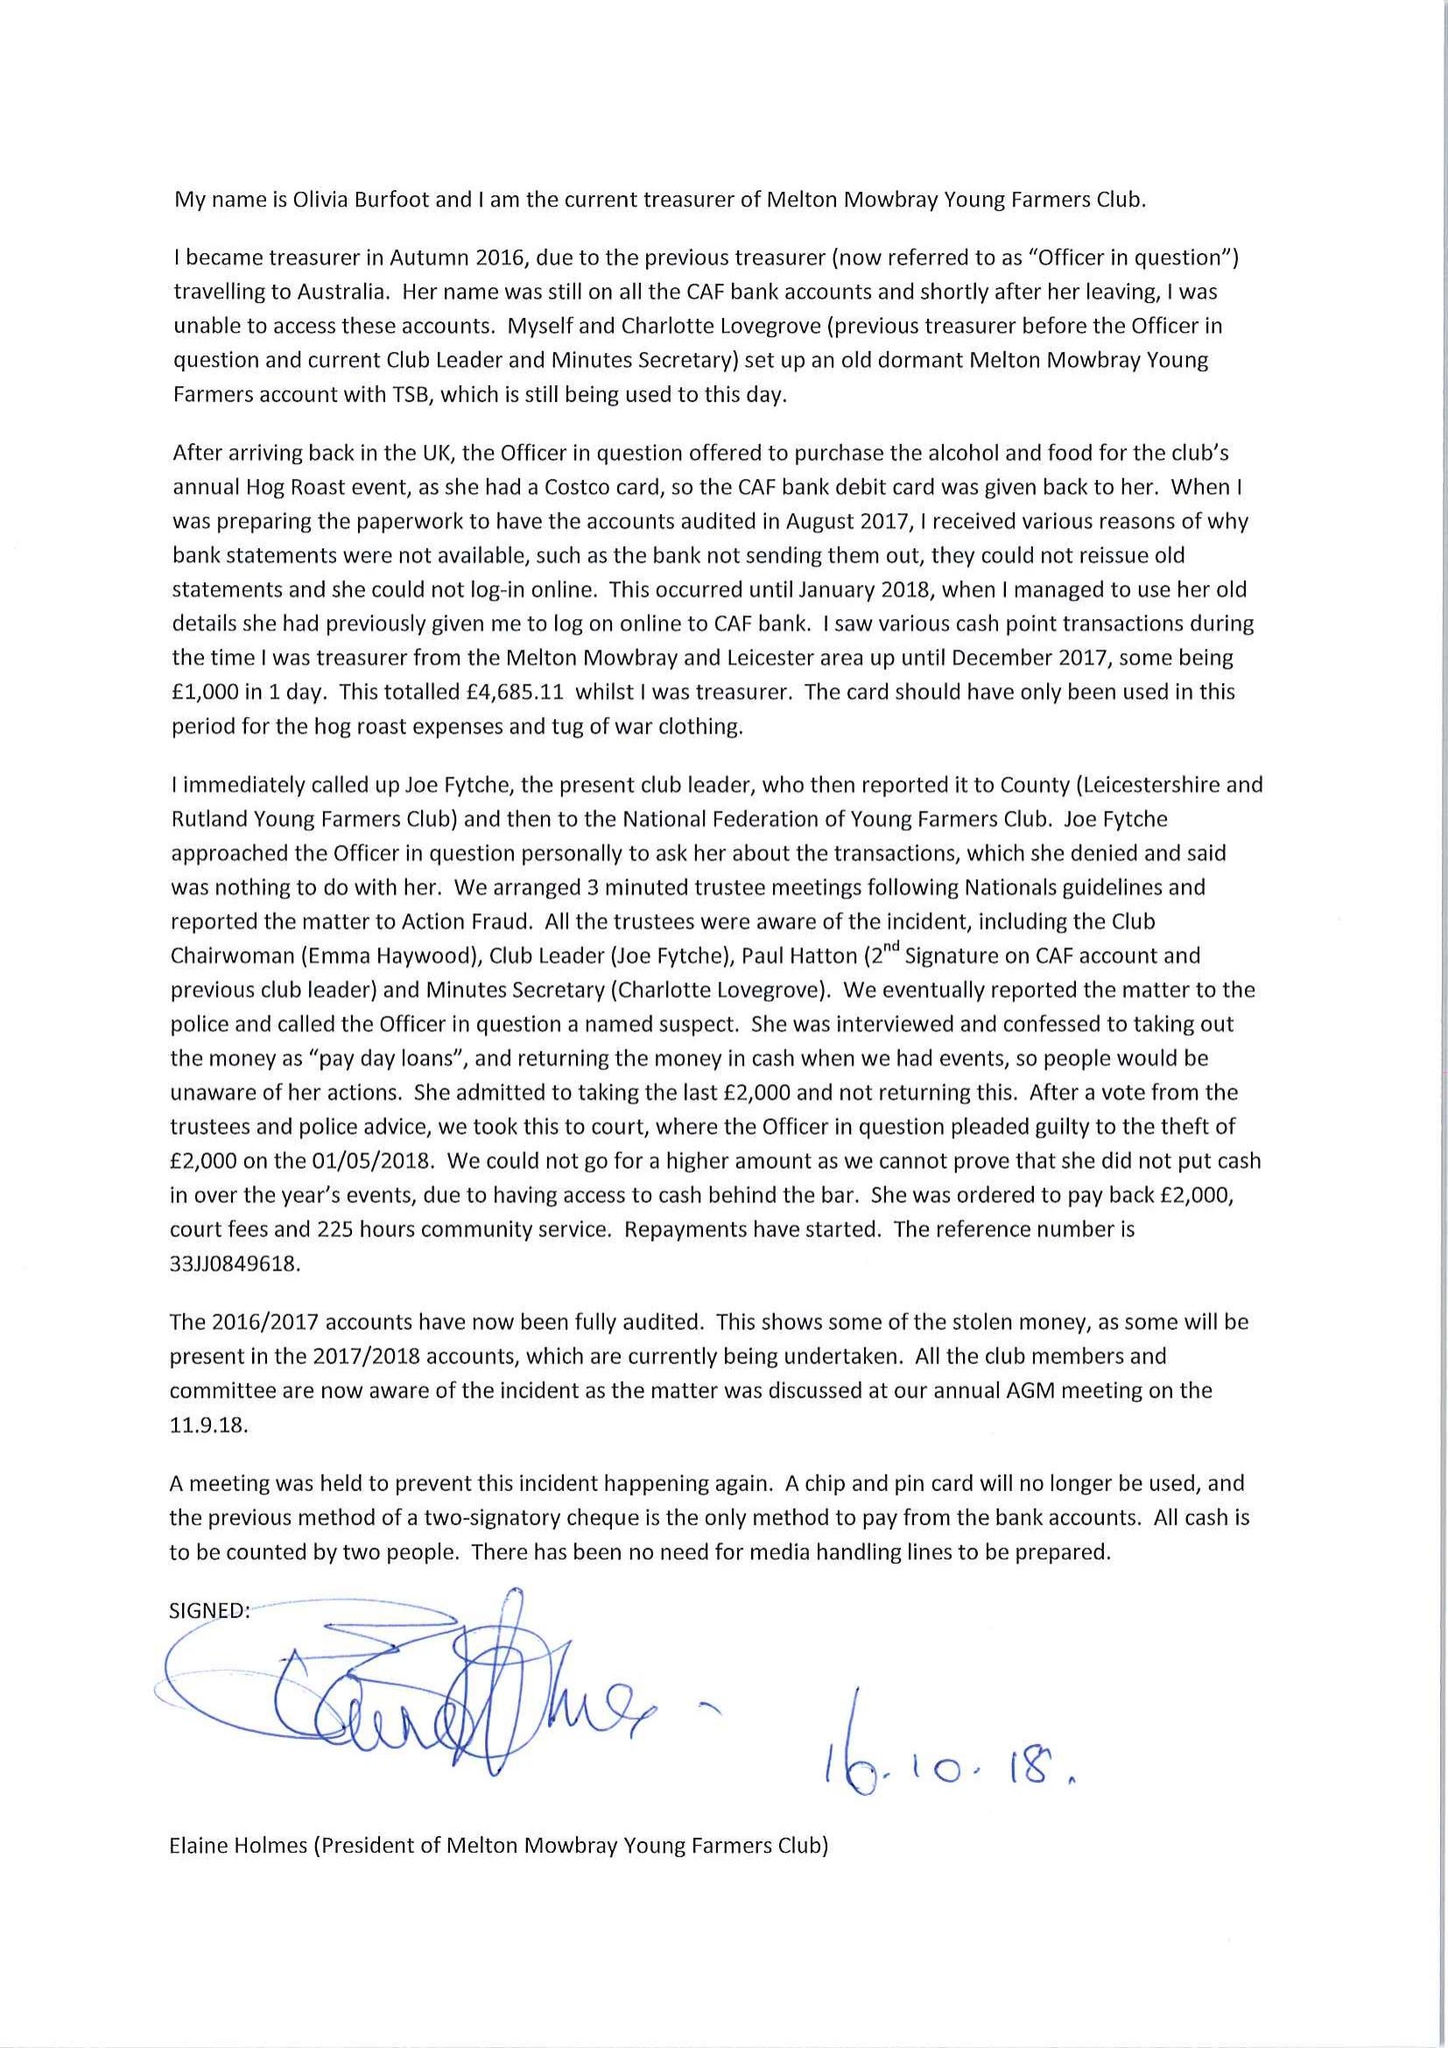What is the value for the address__post_town?
Answer the question using a single word or phrase. MELTON MOWBRAY 